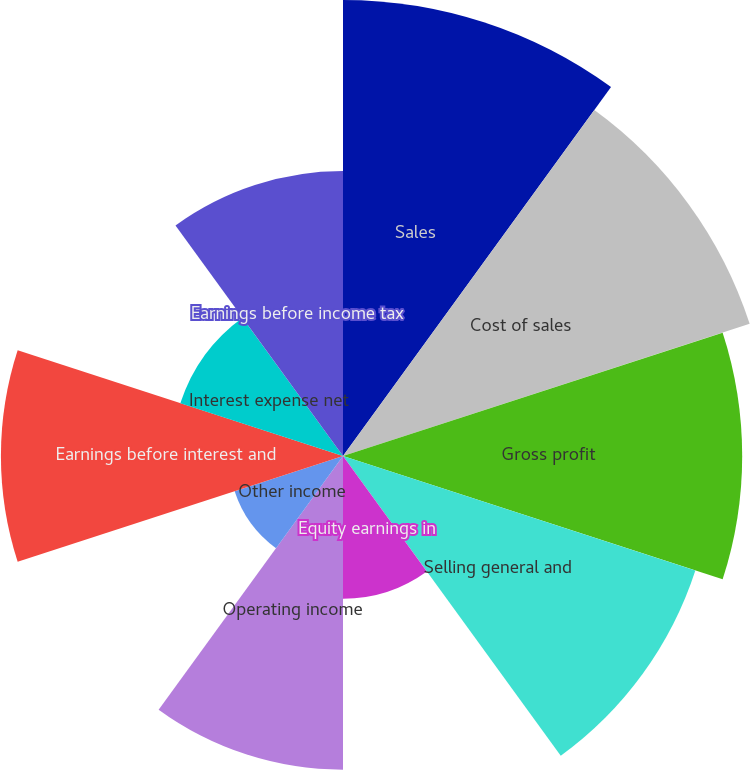Convert chart to OTSL. <chart><loc_0><loc_0><loc_500><loc_500><pie_chart><fcel>Sales<fcel>Cost of sales<fcel>Gross profit<fcel>Selling general and<fcel>Equity earnings in<fcel>Operating income<fcel>Other income<fcel>Earnings before interest and<fcel>Interest expense net<fcel>Earnings before income tax<nl><fcel>15.09%<fcel>14.15%<fcel>13.21%<fcel>12.26%<fcel>4.72%<fcel>10.38%<fcel>3.77%<fcel>11.32%<fcel>5.66%<fcel>9.43%<nl></chart> 